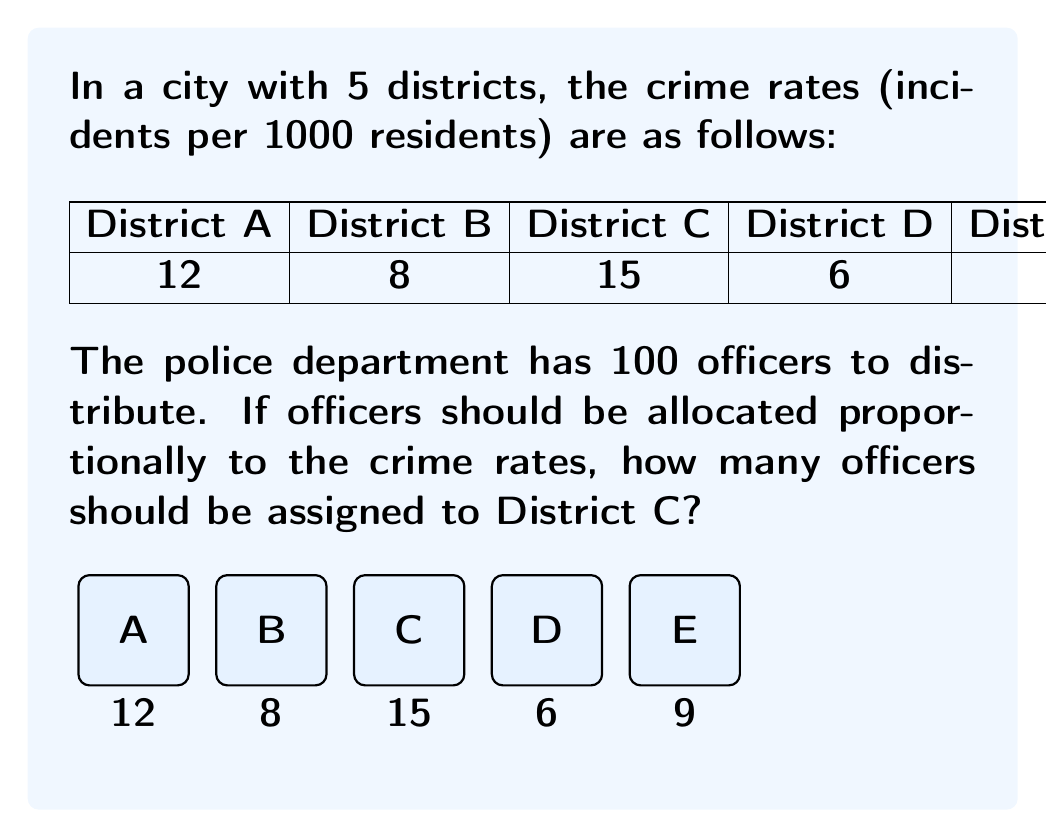Give your solution to this math problem. To solve this problem, we'll follow these steps:

1) Calculate the total crime rate across all districts:
   $12 + 8 + 15 + 6 + 9 = 50$ incidents per 1000 residents

2) Calculate the proportion of crime in District C:
   $\frac{15}{50} = 0.3$ or 30%

3) Since officers should be allocated proportionally to crime rates, District C should receive 30% of the officers.

4) Calculate 30% of 100 officers:
   $100 \times 0.3 = 30$ officers

Therefore, 30 officers should be assigned to District C.

This distribution ensures that the number of officers in each district is proportional to its crime rate, which aligns with the principle of allocating resources where they're most needed.
Answer: 30 officers 